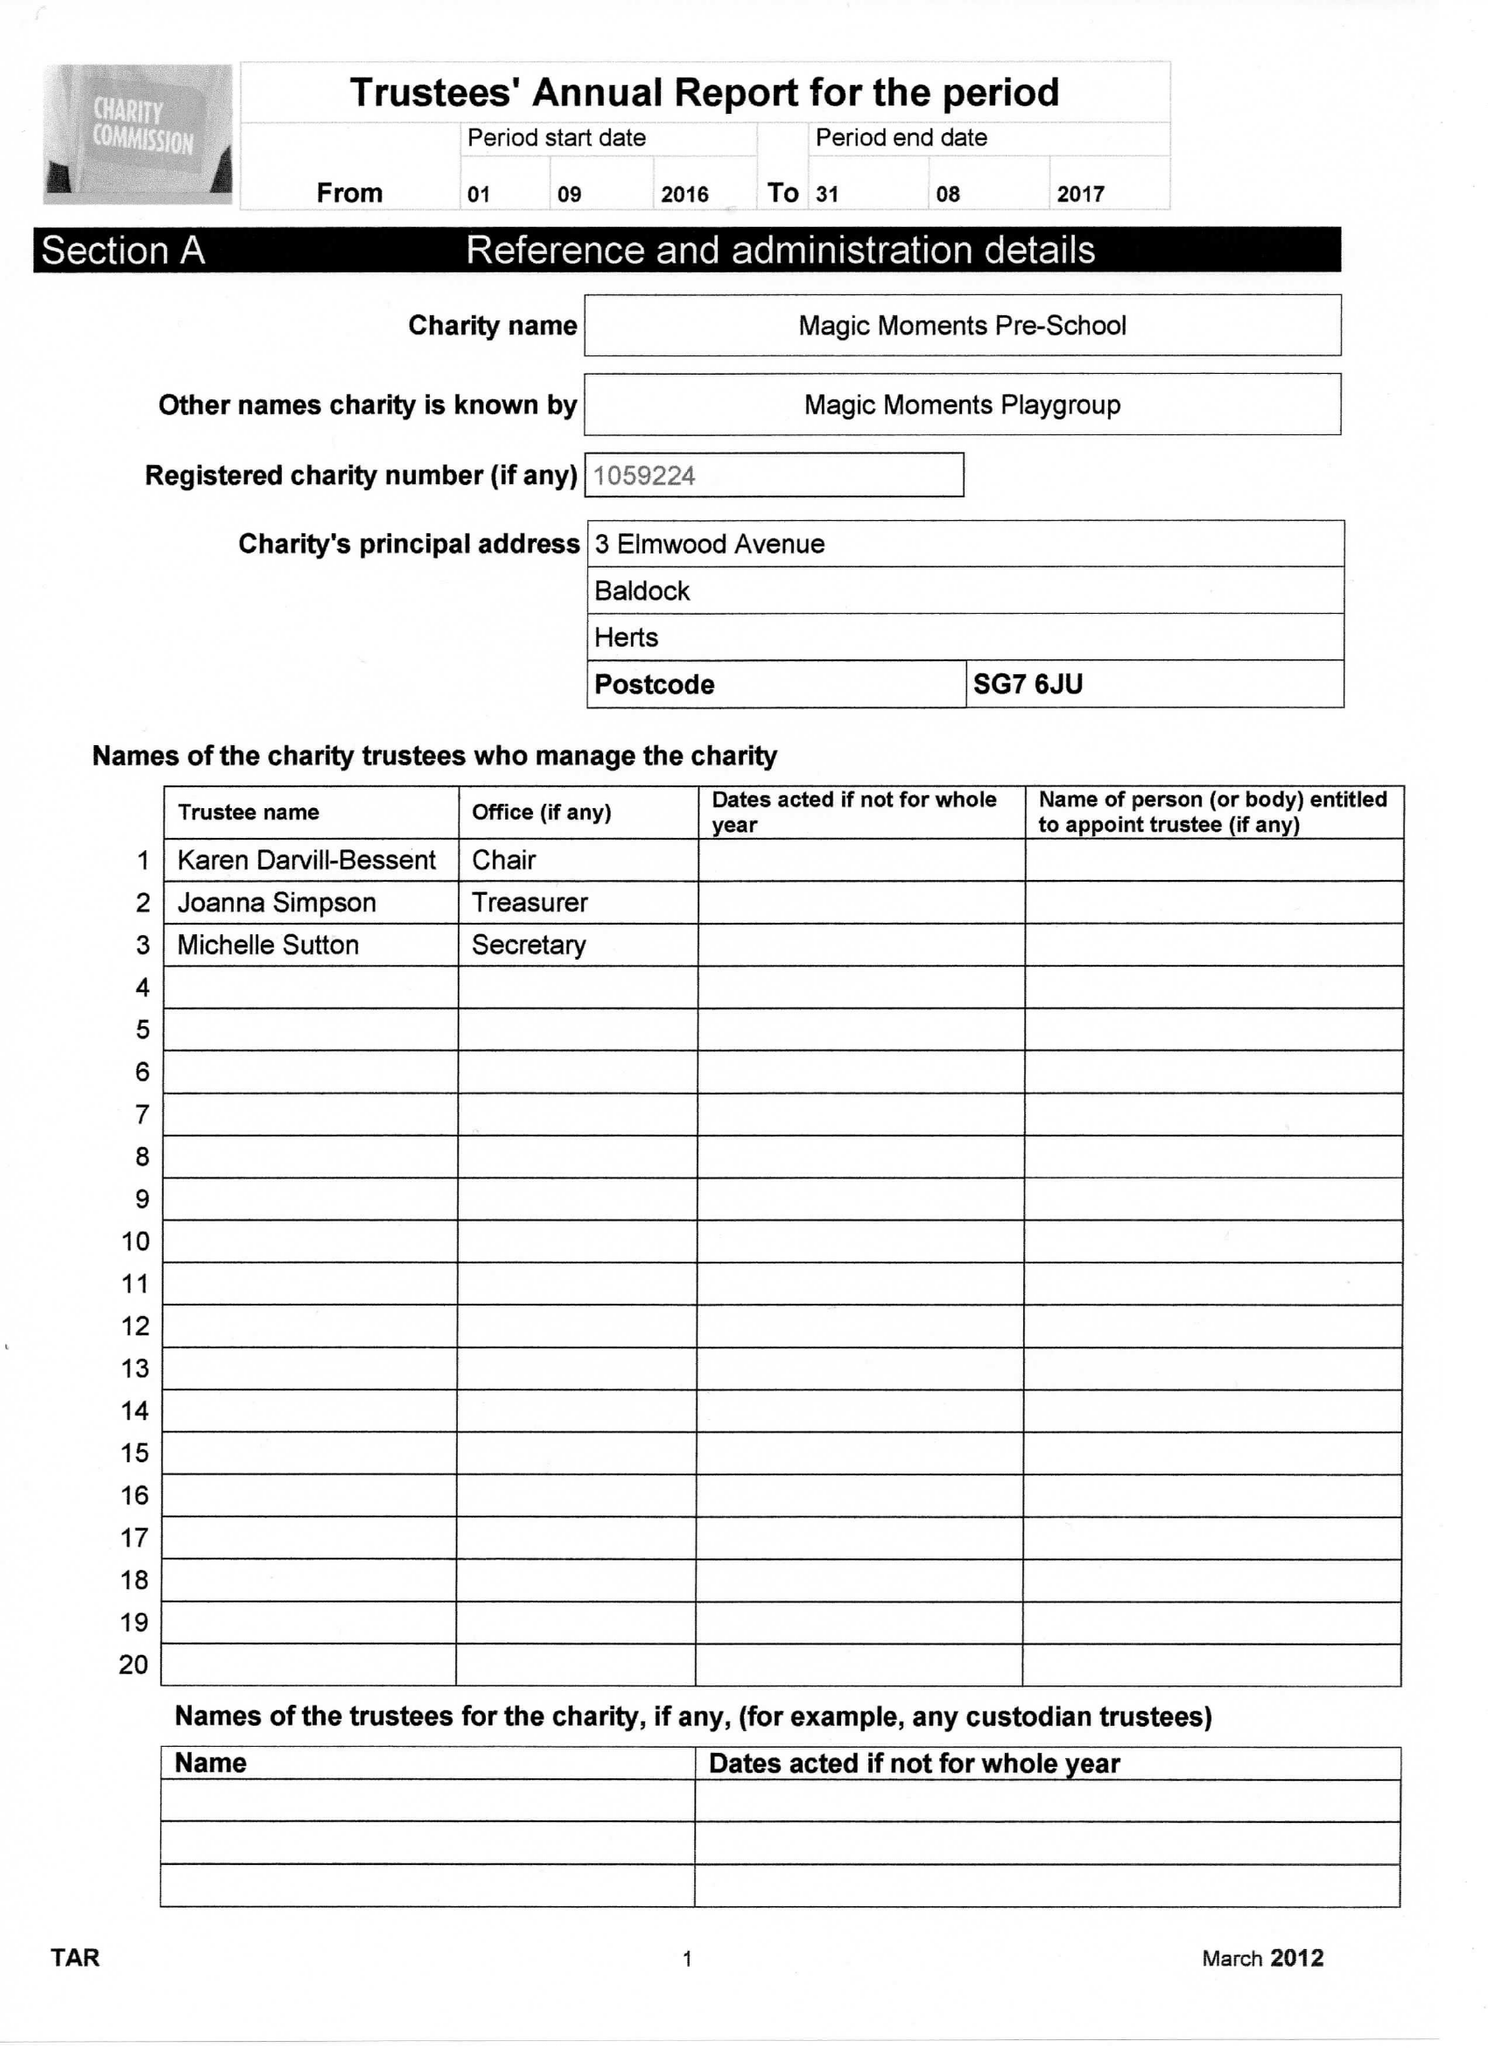What is the value for the charity_name?
Answer the question using a single word or phrase. Magic Moments Playgroup 